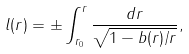Convert formula to latex. <formula><loc_0><loc_0><loc_500><loc_500>l ( r ) = \pm \int _ { r _ { 0 } } ^ { r } \frac { d r } { \sqrt { 1 - b ( r ) / r } } ,</formula> 